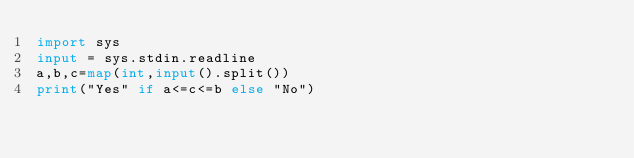Convert code to text. <code><loc_0><loc_0><loc_500><loc_500><_Python_>import sys
input = sys.stdin.readline
a,b,c=map(int,input().split())
print("Yes" if a<=c<=b else "No")
</code> 